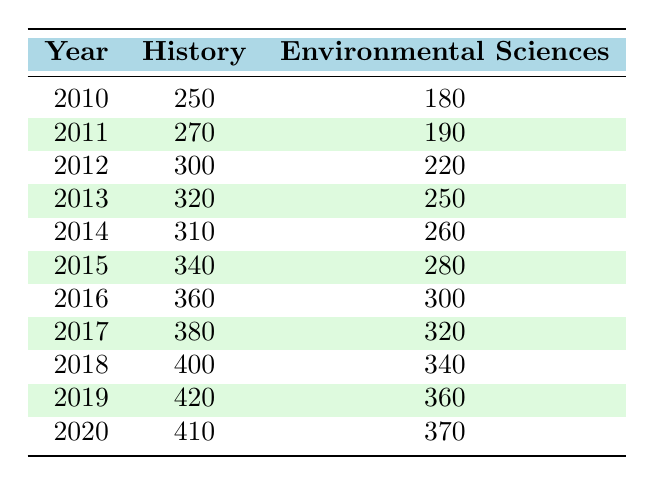What was the enrollment for History in 2012? Referring to the table, under the year 2012, the enrollment for History is directly given as 300.
Answer: 300 What was the enrollment for Environmental Sciences in 2019? The table indicates that in 2019, the enrollment for Environmental Sciences is 360.
Answer: 360 Which year had the highest enrollment for History? By examining the table, the year with the highest enrollment for History is 2019, with an enrollment of 420.
Answer: 2019 What is the difference in enrollment for Environmental Sciences between 2010 and 2015? From the table, the enrollment for Environmental Sciences in 2010 is 180 and in 2015 is 280. The difference is calculated as 280 - 180 = 100.
Answer: 100 What was the average enrollment for History from 2010 to 2020? To find the average, sum the enrollments: 250 + 270 + 300 + 320 + 310 + 340 + 360 + 380 + 400 + 410 =  3240. There are 11 data points (years 2010 to 2020), so the average is 3240 / 11 = 294.55, which rounds to 295.
Answer: 295 Did the enrollment for Environmental Sciences ever exceed 300 from 2010 to 2020? Checking the values, the highest enrollment for Environmental Sciences in the table is 370 in the year 2020. Thus, it does exceed 300.
Answer: Yes In what year did the enrollment for Environmental Sciences increase the most over the previous year? Analyzing the table, the greatest increase occurred from 2018 (340) to 2019 (360), which is an increase of 20. The next largest increase is from 2016 (300) to 2017 (320), which is 20 as well.
Answer: 2018-2019 What is the total enrollment for both programs in 2014? In 2014, the enrollment for History is 310 and for Environmental Sciences is 260. Adding these together gives 310 + 260 = 570.
Answer: 570 How many more students were enrolled in History than Environmental Sciences in 2018? In 2018, History had an enrollment of 400 while Environmental Sciences had 340. The difference is 400 - 340 = 60.
Answer: 60 What was the trend in enrollment for Environmental Sciences over the years? By looking through the table, it is evident that enrollment in Environmental Sciences shows a gradual upward trend from 180 in 2010 to 370 in 2020, with steady increases each year.
Answer: Upward trend 